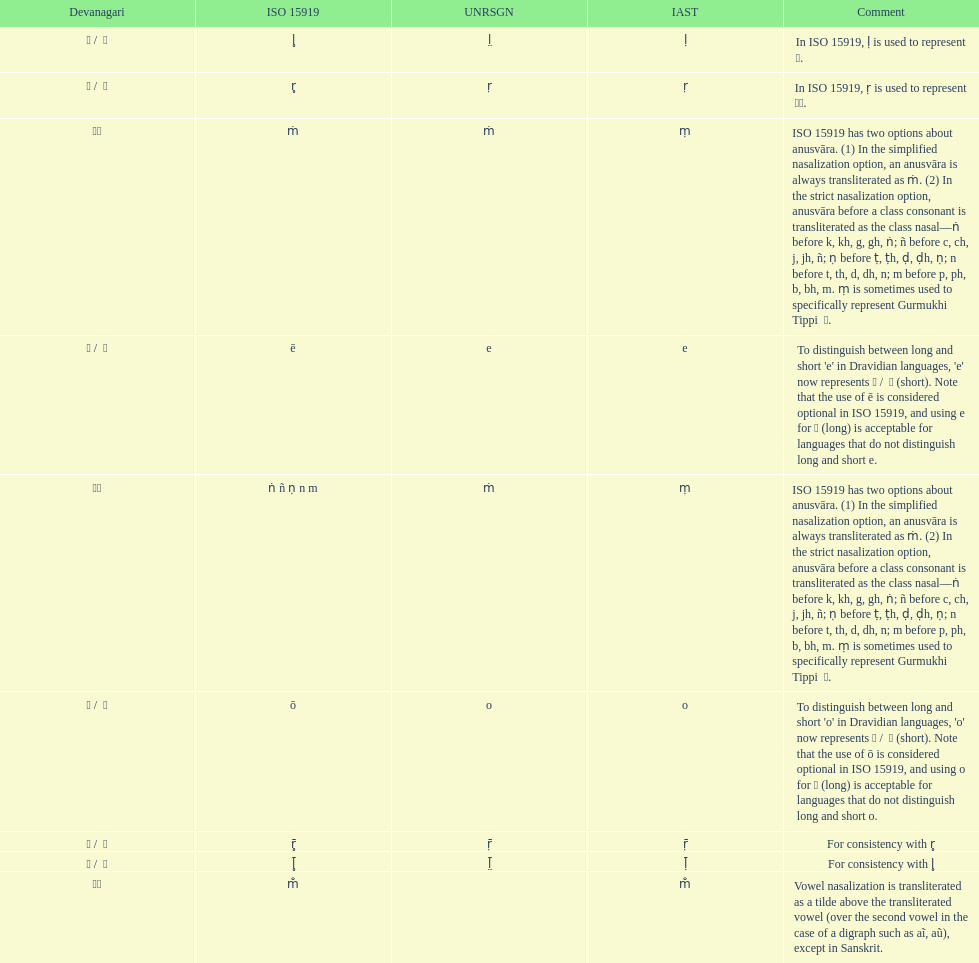Which devanagari transliteration is listed on the top of the table? ए / े. 